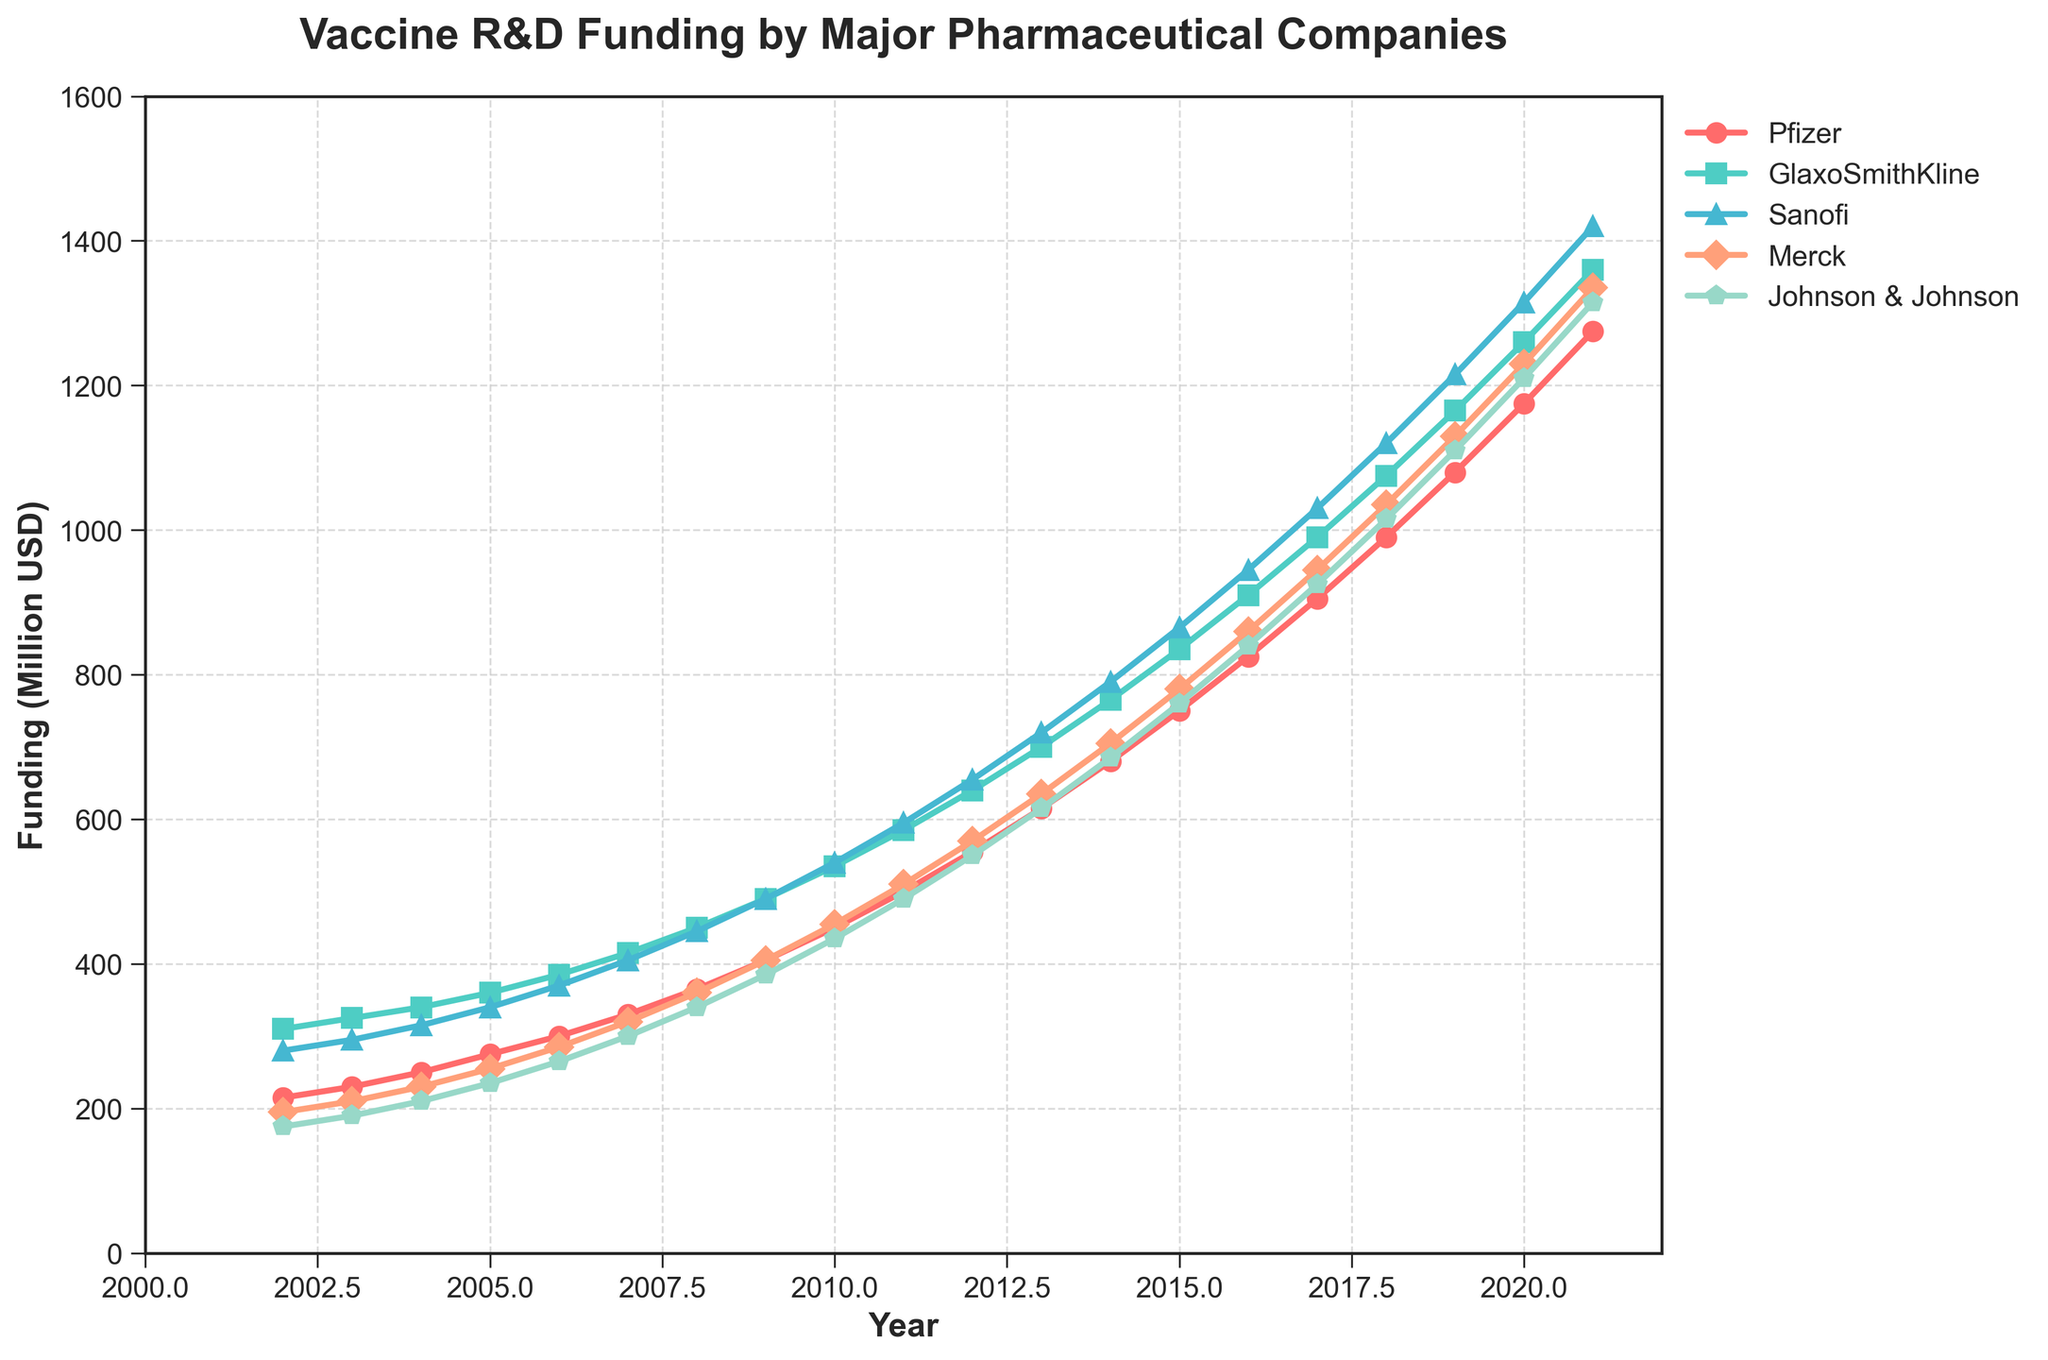What was the trend of Pfizer's vaccine R&D funding from 2002 to 2021? To determine the trend, look at the line representing Pfizer in the chart. Notice the overall direction and pattern. Pfizer's funding increases steadily from around 215 million USD in 2002 to 1275 million USD in 2021.
Answer: Steadily increasing Between which years did Johnson & Johnson's funding see the most significant increase? Identify the segments of the Johnson & Johnson curve with the steepest positive slope. The funding sees the most significant increase between 2019 and 2021, rising from 1110 million USD to 1315 million USD.
Answer: 2019 to 2021 Which company had the highest vaccine R&D funding in 2021? Compare the values for each company in 2021 by looking at the y-values of the lines at the rightmost end. GlaxoSmithKline has the highest funding level at around 1360 million USD.
Answer: GlaxoSmithKline What is the difference in vaccine R&D funding between Merck and Sanofi in 2015? Locate the points for Merck and Sanofi in 2015, then subtract Merck's funding (780 million USD) from Sanofi's funding (865 million USD). The difference is 85 million USD.
Answer: 85 million USD Calculate the average vaccine R&D funding for GlaxoSmithKline from 2017 to 2021. Identify GlaxoSmithKline's funding values from 2017 to 2021 (990, 1075, 1165, 1260, 1360 million USD). Sum these values (5850 million USD) and then divide by the number of years (5). The average is 1170 million USD.
Answer: 1170 million USD Which company showed a more consistent year-over-year funding increase, Pfizer or Merck? Compare the smoothness and steadiness of the lines for Pfizer and Merck. Pfizer's funding increases relatively smoothly each year, while Merck's line has more variability and less consistency.
Answer: Pfizer How many companies had vaccine R&D funding exceeding 1000 million USD in 2020? Check the y-values in 2020 for each company. Pfizer, GlaxoSmithKline, Sanofi, and Johnson & Johnson have funding exceeding 1000 million USD. Four companies meet this criterion.
Answer: 4 What was the total vaccine R&D funding for all companies combined in 2013? Sum the funding values for all five companies in 2013 (Pfizer: 615, GlaxoSmithKline: 700, Sanofi: 720, Merck: 635, Johnson & Johnson: 615). The total funding is 3285 million USD.
Answer: 3285 million USD In which year did GlaxoSmithKline's funding first exceed 500 million USD? Identify the year where GlaxoSmithKline's line crosses the 500 million USD threshold. This occurs in 2010.
Answer: 2010 Compare the increase in funding from 2002 to 2021 for Sanofi and Merck and state which company had a larger increase. For Sanofi, subtract the 2002 value (280 million USD) from the 2021 value (1420 million USD), resulting in a 1140 million USD increase. For Merck, subtract the 2002 value (195 million USD) from the 2021 value (1335 million USD), resulting in a 1140 million USD increase as well. Both companies had the same increase.
Answer: Both had the same increase 